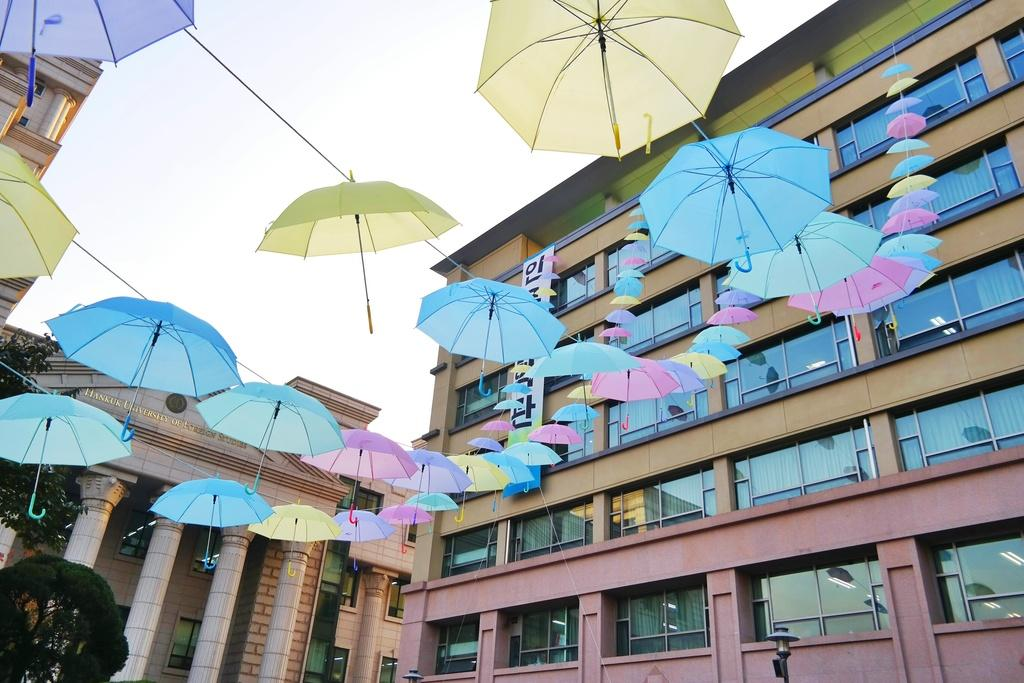What objects can be seen in the image? There are umbrellas in the image. What colors are the umbrellas? The umbrellas are in pink, blue, and yellow colors. What can be seen in the background of the image? There are buildings in the background of the image. What color are the buildings? The buildings are in brown color. What is visible in the sky in the image? The sky is visible in the image. What color is the sky? The sky is in white color. How many cakes are being sold at the payment counter in the image? There is no payment counter or cakes present in the image. Is the hot weather affecting the umbrellas in the image? The image does not provide information about the weather, and there is no indication that the umbrellas are affected by any specific weather conditions. 